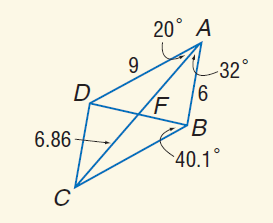Answer the mathemtical geometry problem and directly provide the correct option letter.
Question: Use parallelogram A B C D to find B C.
Choices: A: 6 B: 9 C: 12 D: 18 B 